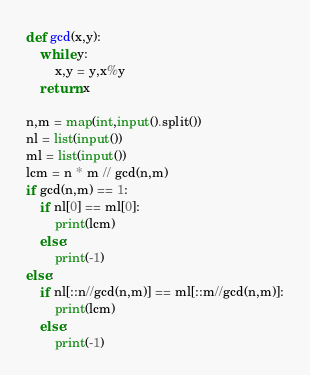<code> <loc_0><loc_0><loc_500><loc_500><_Python_>def gcd(x,y):
    while y:
        x,y = y,x%y
    return x

n,m = map(int,input().split())
nl = list(input())
ml = list(input())
lcm = n * m // gcd(n,m)
if gcd(n,m) == 1:
    if nl[0] == ml[0]:
        print(lcm)
    else:
        print(-1)
else:
    if nl[::n//gcd(n,m)] == ml[::m//gcd(n,m)]:
        print(lcm)
    else:
        print(-1)</code> 